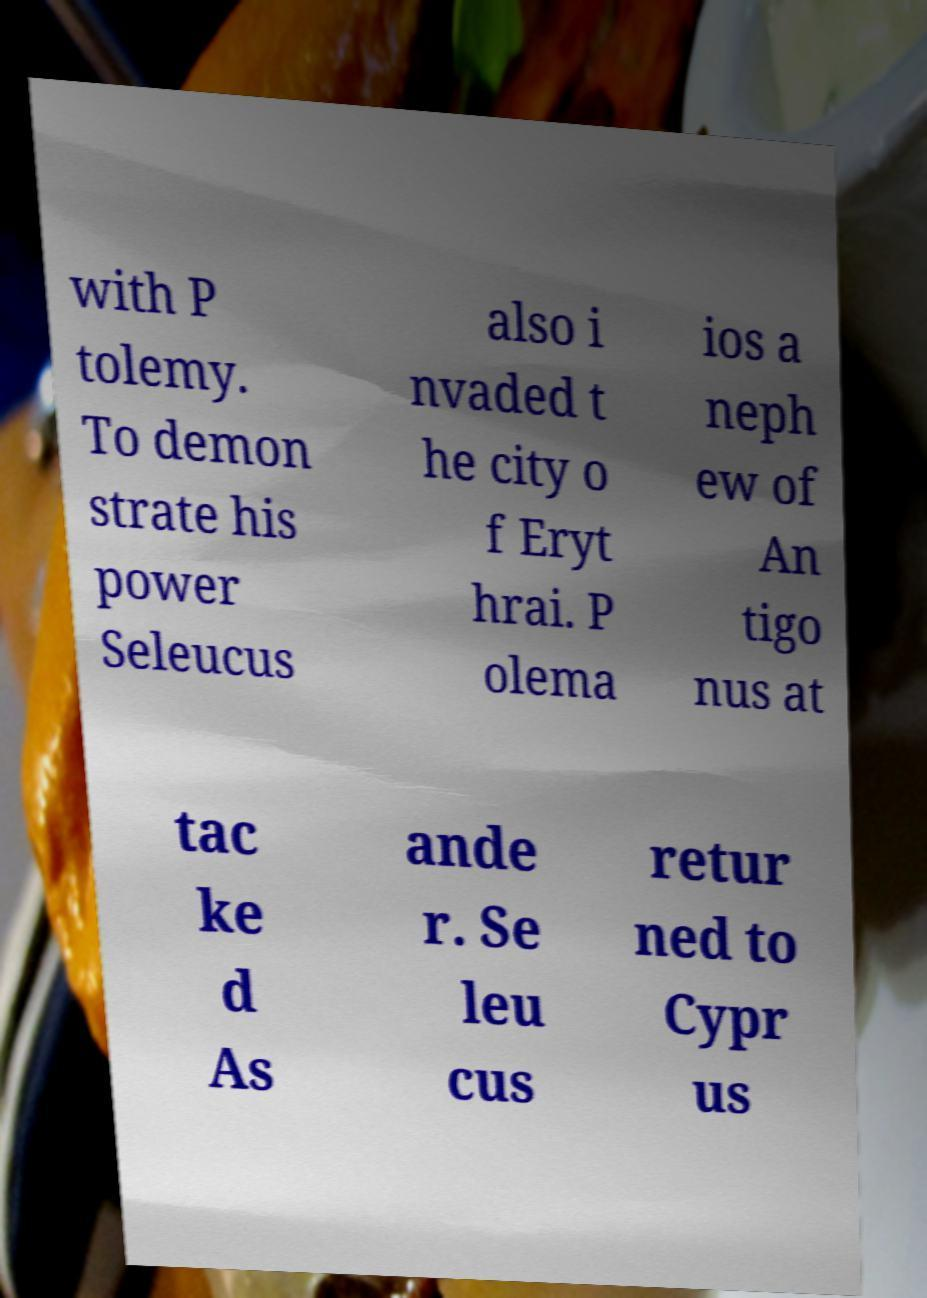Can you accurately transcribe the text from the provided image for me? with P tolemy. To demon strate his power Seleucus also i nvaded t he city o f Eryt hrai. P olema ios a neph ew of An tigo nus at tac ke d As ande r. Se leu cus retur ned to Cypr us 